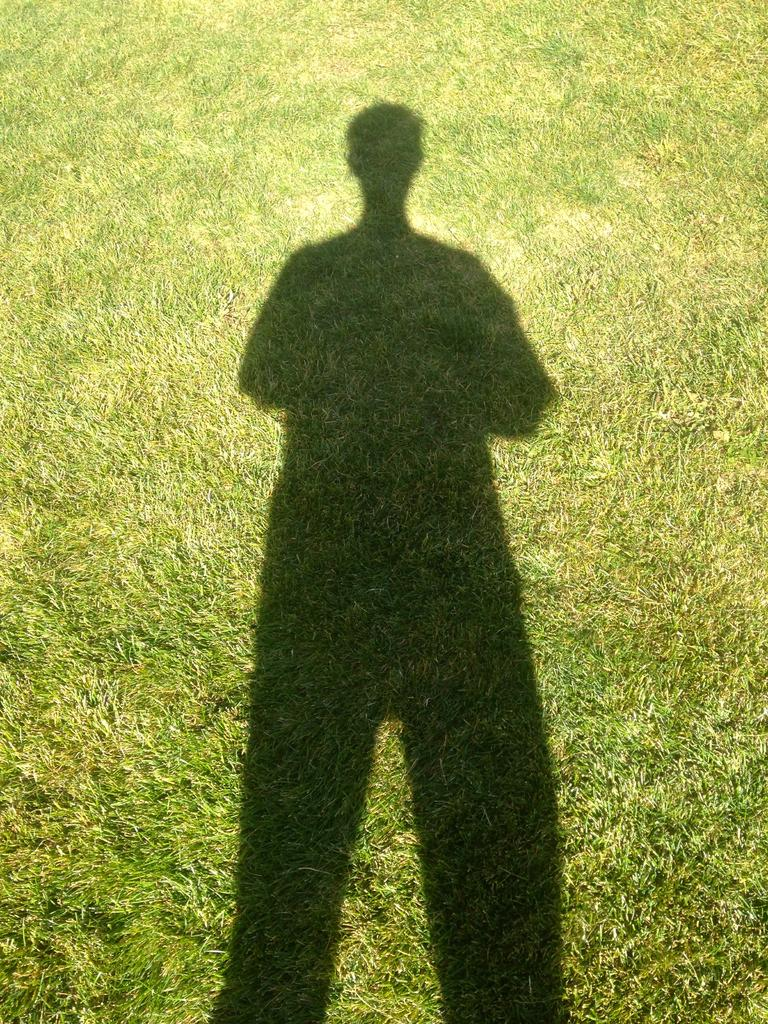What type of surface is visible on the ground in the image? There is grass on the ground in the image. Can you describe any other elements in the image besides the grass? Yes, there is a shadow of a person in the image. What type of street is visible in the image? There is no street visible in the image; it only shows grass and a shadow of a person. What type of popcorn can be seen in the image? There is no popcorn present in the image. 